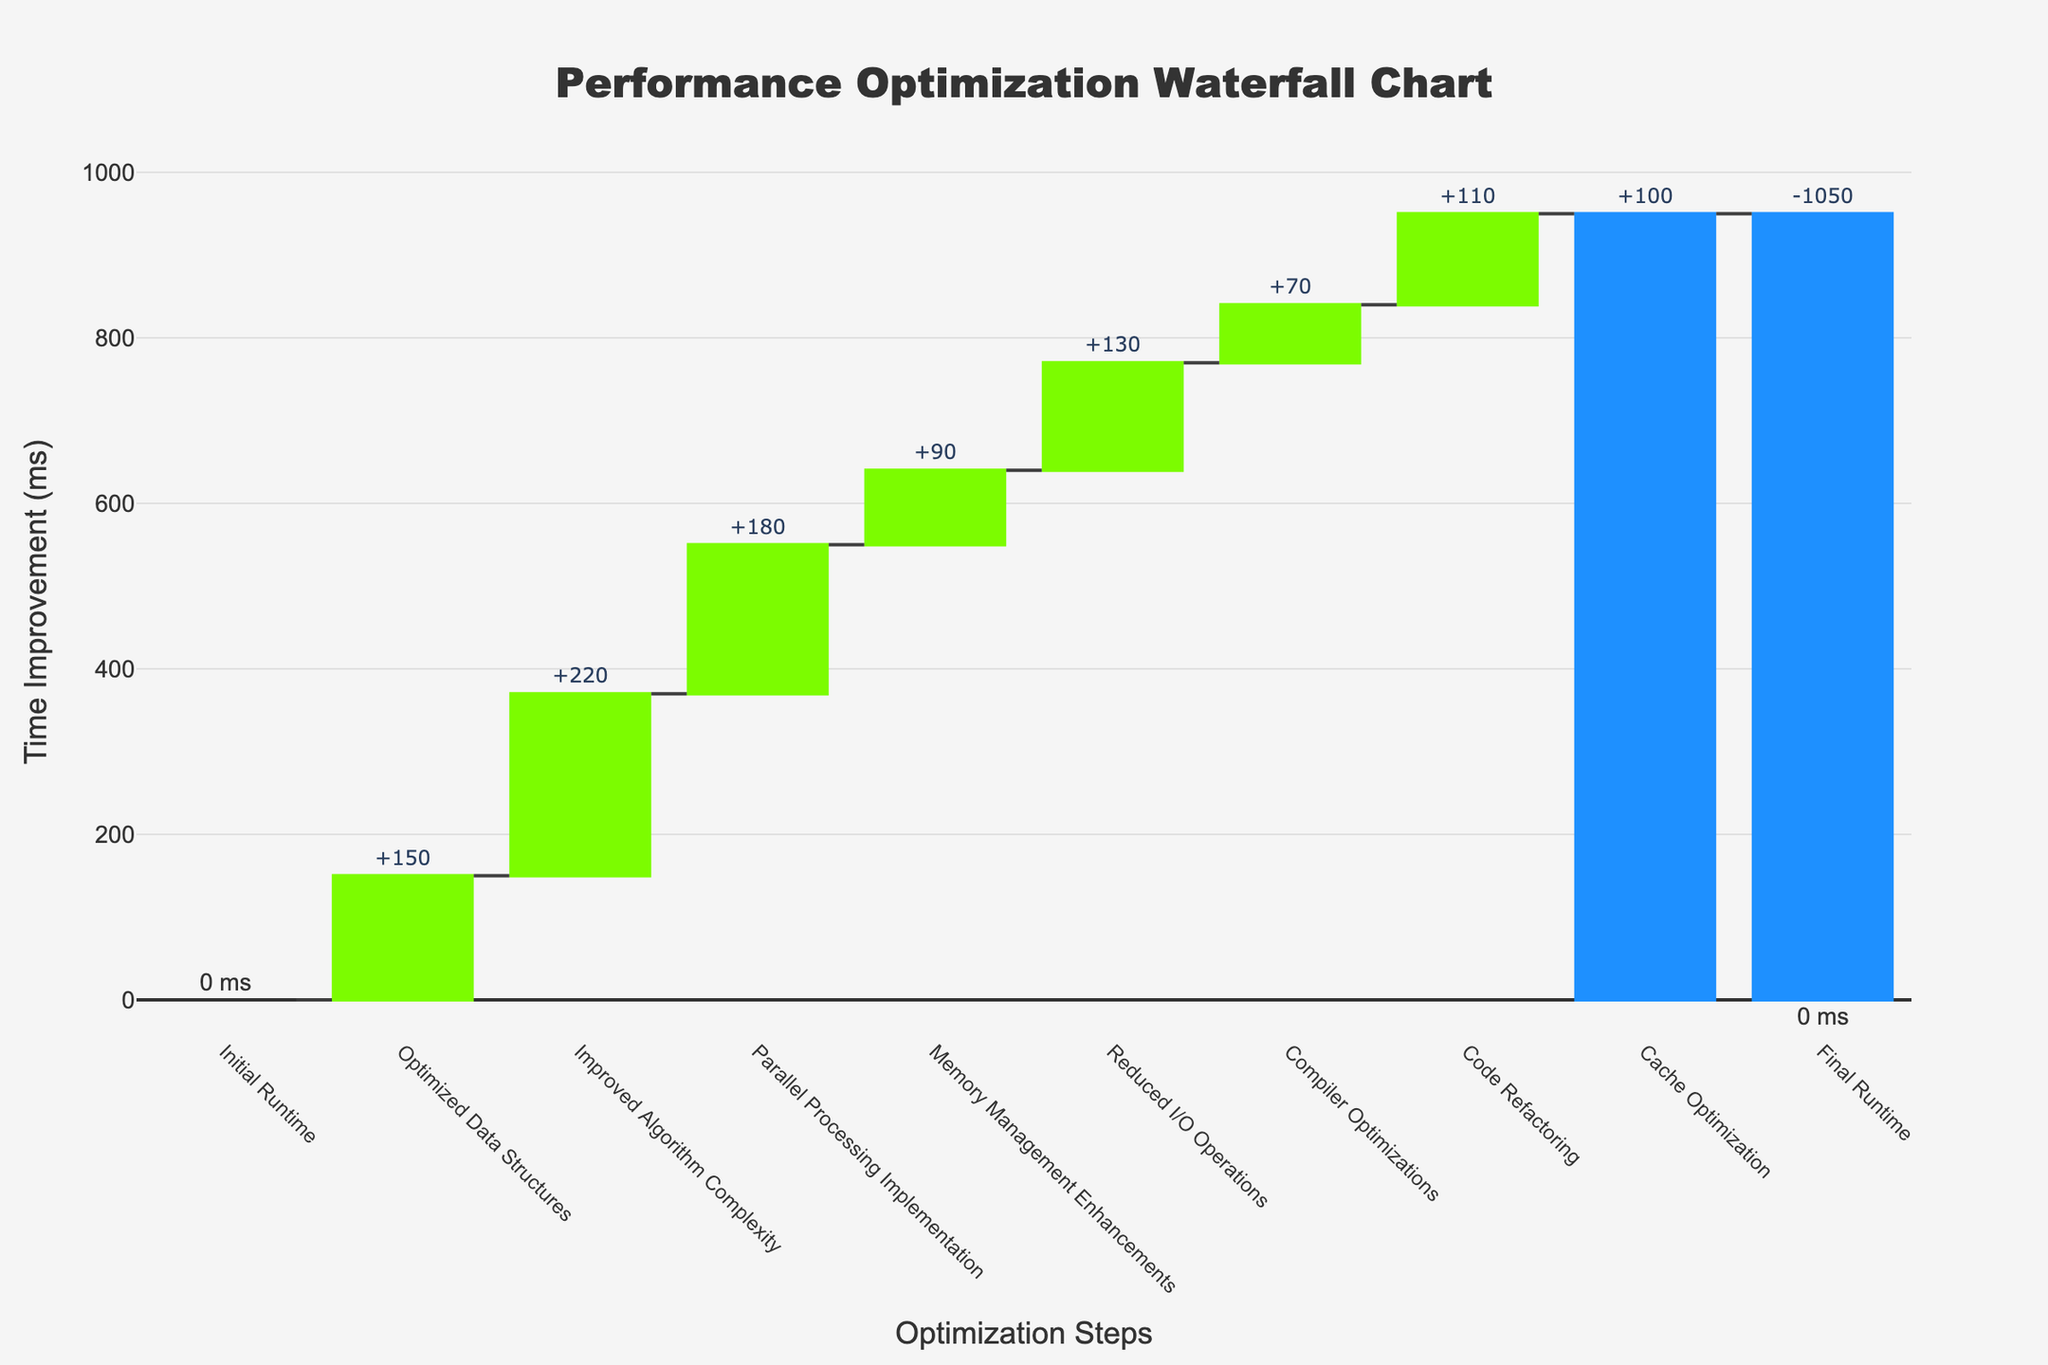How many steps are shown in the Waterfall Chart? There are labels for each step on the x-axis. Counting each unique label provides the number of steps.
Answer: 9 Which optimization step resulted in the highest time improvement? Look at the height of the green bars, which represent positive improvements. "Improved Algorithm Complexity" appears to have the tallest green bar.
Answer: Improved Algorithm Complexity What is the total time improvement before applying the "Final Runtime"? Sum the values of the green and red bars before the "Final Runtime" step. The cumulative improvements are: 150 + 220 + 180 + 90 + 130 + 70 + 110 + 100.
Answer: 1050 ms What is the overall effect of "Memory Management Enhancements" compared to "Cache Optimization"? "Memory Management Enhancements" has a time improvement of 90 ms and "Cache Optimization" has a time improvement of 100 ms. Comparing these values shows that "Cache Optimization" has a greater impact.
Answer: Cache Optimization has a greater impact By how much did "Parallel Processing Implementation" improve performance compared to "Optimized Data Structures"? Subtract the improvement from "Optimized Data Structures" (150 ms) from "Parallel Processing Implementation" (180 ms). 180 - 150 = 30 ms.
Answer: 30 ms What's the overall percentage improvement in performance if the initial runtime is considered to be 1050 ms? Calculate the percentage decrease by dividing the final cumulative improvement (1050) by the initial runtime (1050) and multiplying by 100. (1050 / 1050) * 100 = 100%.
Answer: 100% Which steps resulted in an improvement greater than 100 ms? Check the time improvements and identify those exceeding 100 ms: "Optimized Data Structures" (150 ms), "Improved Algorithm Complexity" (220 ms), "Parallel Processing Implementation" (180 ms), "Reduced I/O Operations" (130 ms), "Code Refactoring" (110 ms), "Cache Optimization" (100 ms just meets the threshold).
Answer: Five steps: Optimized Data Structures, Improved Algorithm Complexity, Parallel Processing Implementation, Reduced I/O Operations, Code Refactoring 